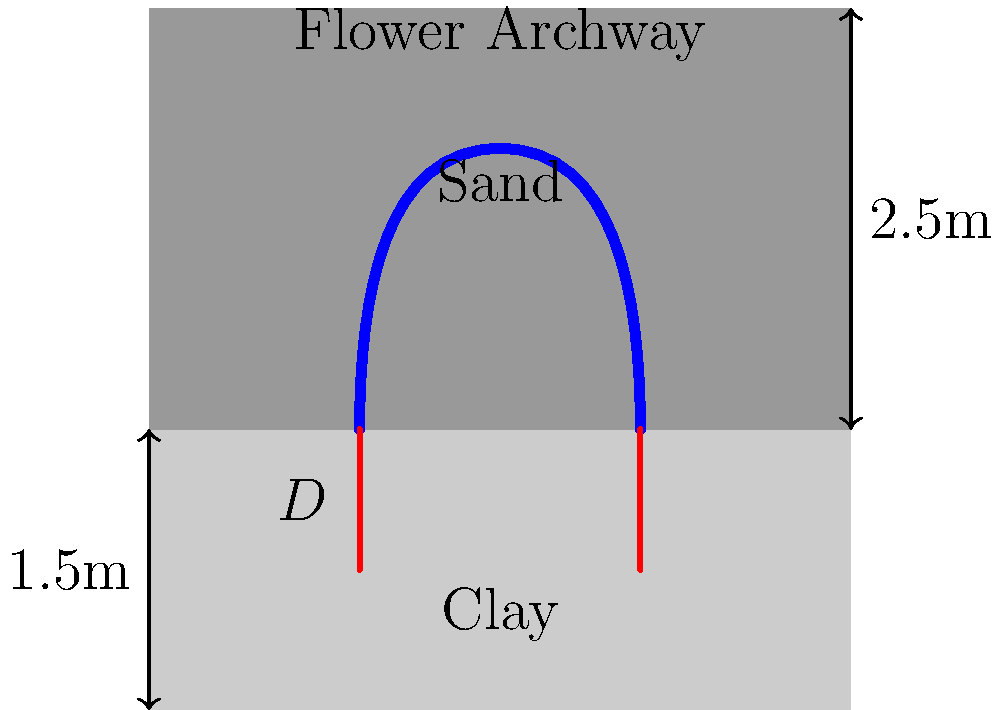A flower archway for a wedding ceremony is to be installed on a two-layer soil profile consisting of 1.5m of clay overlying sand. The archway weighs 500 kg and has a base width of 4m. Given that the allowable bearing capacity of clay is 150 kN/m² and that of sand is 250 kN/m², calculate the minimum foundation depth (D) required to ensure stability. Assume a safety factor of 2 and that the foundation width is equal to the archway base width. To determine the minimum foundation depth, we'll follow these steps:

1) Convert the archway weight to force:
   $F = 500 \text{ kg} \times 9.81 \text{ m/s²} = 4905 \text{ N} = 4.905 \text{ kN}$

2) Calculate the required bearing capacity with the safety factor:
   $q_{req} = \frac{F \times SF}{A} = \frac{4.905 \text{ kN} \times 2}{4 \text{ m} \times 1 \text{ m}} = 2.45 \text{ kN/m²}$

3) The clay layer has a lower bearing capacity, so we'll use it for calculations:
   $q_{allow} = 150 \text{ kN/m²}$

4) Since $q_{req} < q_{allow}$, the foundation can be placed within the clay layer.

5) Calculate the minimum depth using the bearing capacity equation:
   $q_{allow} = c \times N_c + \gamma \times D \times N_q + 0.5 \times \gamma \times B \times N_\gamma$

   Where:
   $c$ = cohesion of clay (assume 75 kN/m²)
   $\gamma$ = unit weight of clay (assume 18 kN/m³)
   $B$ = foundation width = 4m
   $N_c, N_q, N_\gamma$ = bearing capacity factors (assume $N_c = 5.7, N_q = 1, N_\gamma = 0$ for clay)

6) Substituting values:
   $150 = 75 \times 5.7 + 18 \times D \times 1 + 0.5 \times 18 \times 4 \times 0$
   $150 = 427.5 + 18D$

7) Solve for D:
   $18D = 150 - 427.5 = -277.5$
   $D = -15.42 \text{ m}$

8) Since we got a negative value, the minimum depth is actually 0m. However, for practical purposes and frost protection, we should use a minimum depth of 0.5m.
Answer: 0.5 m 